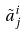<formula> <loc_0><loc_0><loc_500><loc_500>\tilde { a } _ { j } ^ { i }</formula> 